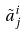<formula> <loc_0><loc_0><loc_500><loc_500>\tilde { a } _ { j } ^ { i }</formula> 